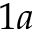Convert formula to latex. <formula><loc_0><loc_0><loc_500><loc_500>1 a</formula> 